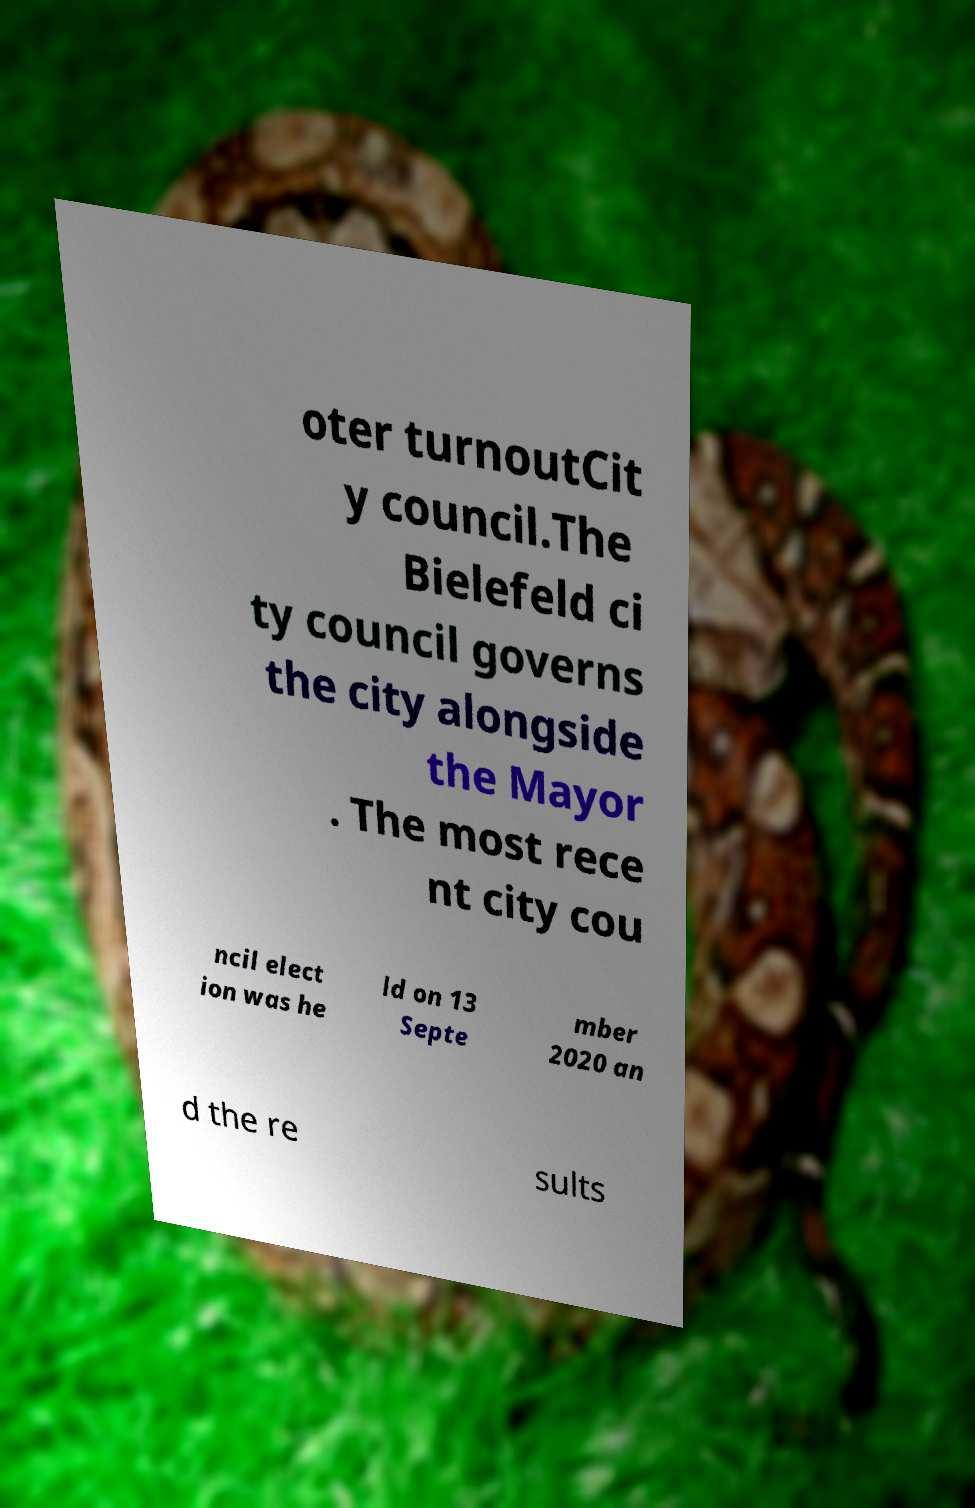For documentation purposes, I need the text within this image transcribed. Could you provide that? oter turnoutCit y council.The Bielefeld ci ty council governs the city alongside the Mayor . The most rece nt city cou ncil elect ion was he ld on 13 Septe mber 2020 an d the re sults 